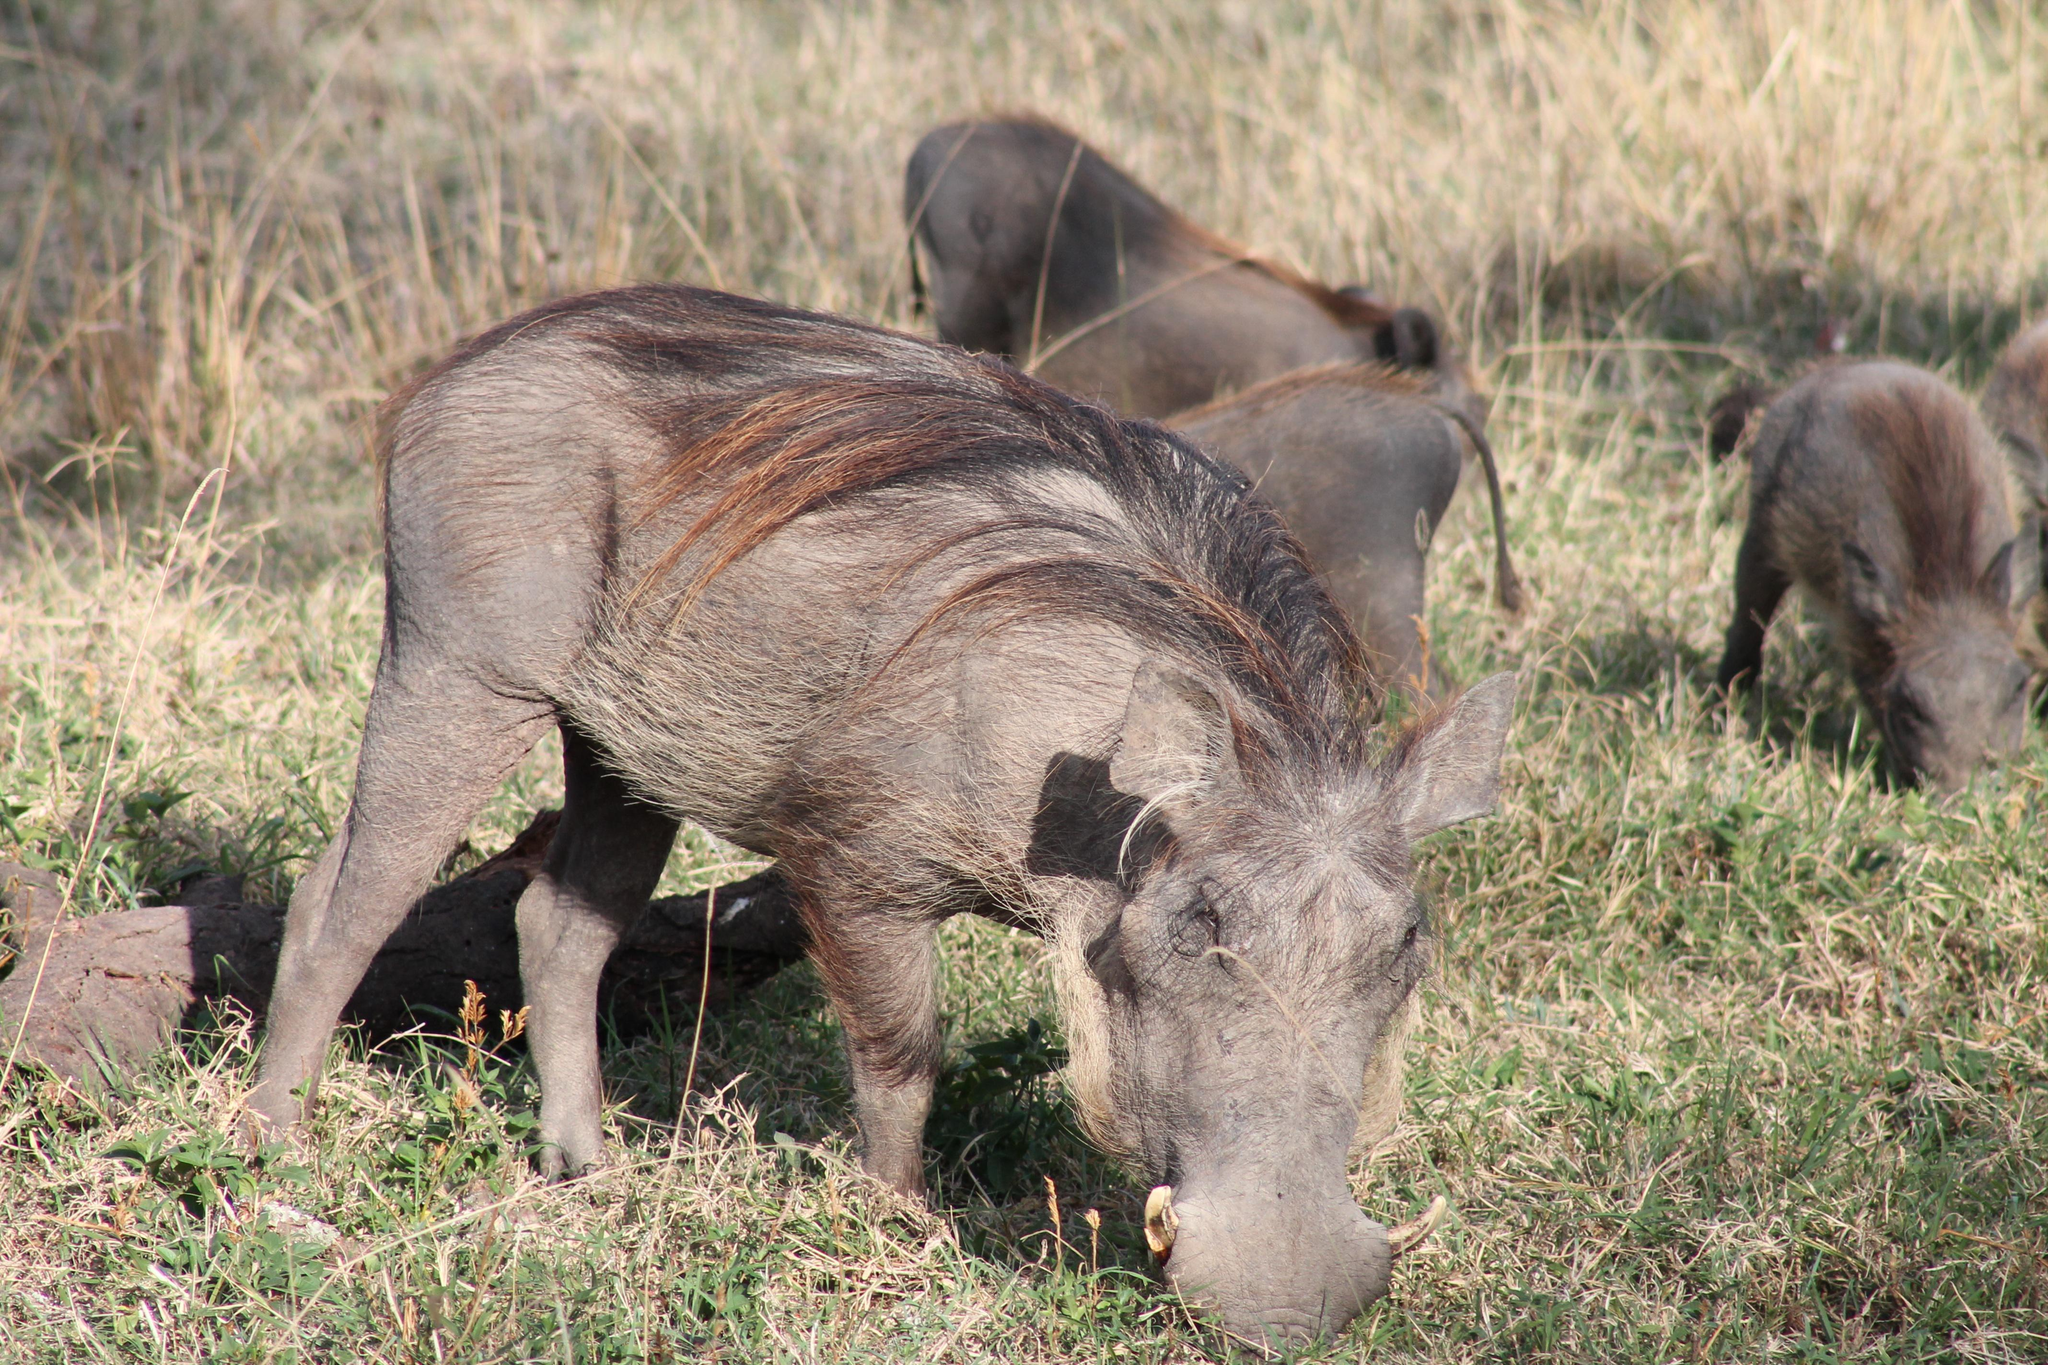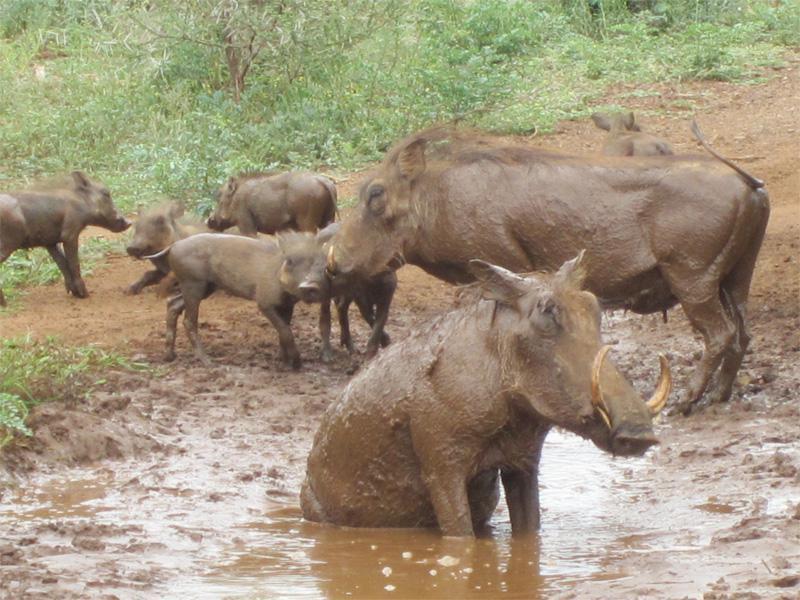The first image is the image on the left, the second image is the image on the right. Considering the images on both sides, is "An image shows a warthog sitting upright, with multiple hogs behind it." valid? Answer yes or no. Yes. 